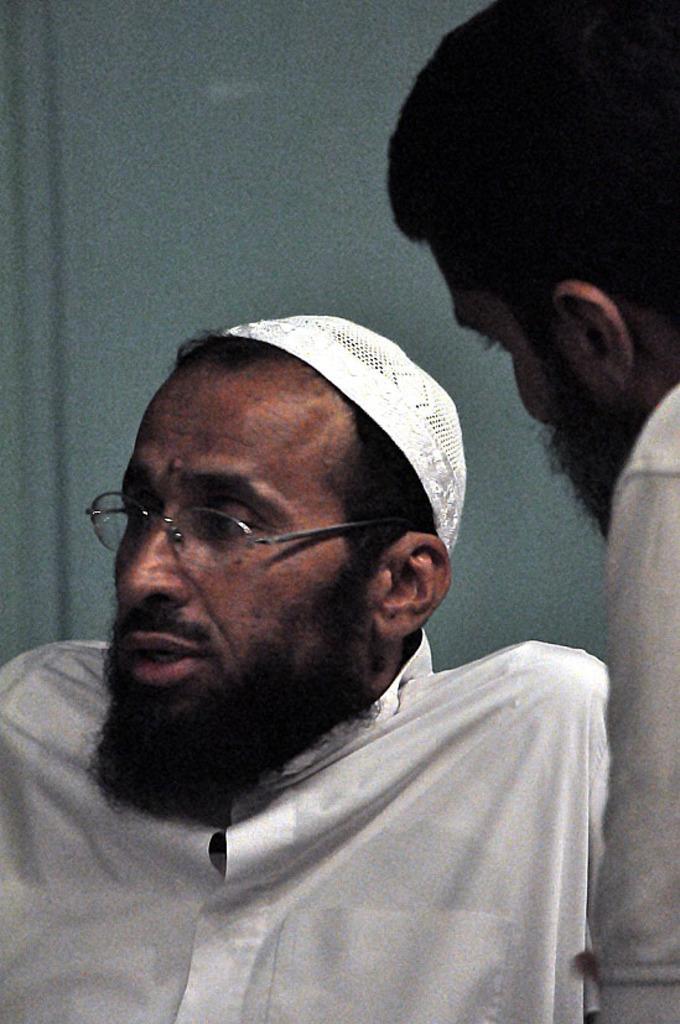Please provide a concise description of this image. In this picture there is a person wearing white dress is having beard and there is a white cap on his head and there is another person beside him in the right corner. 